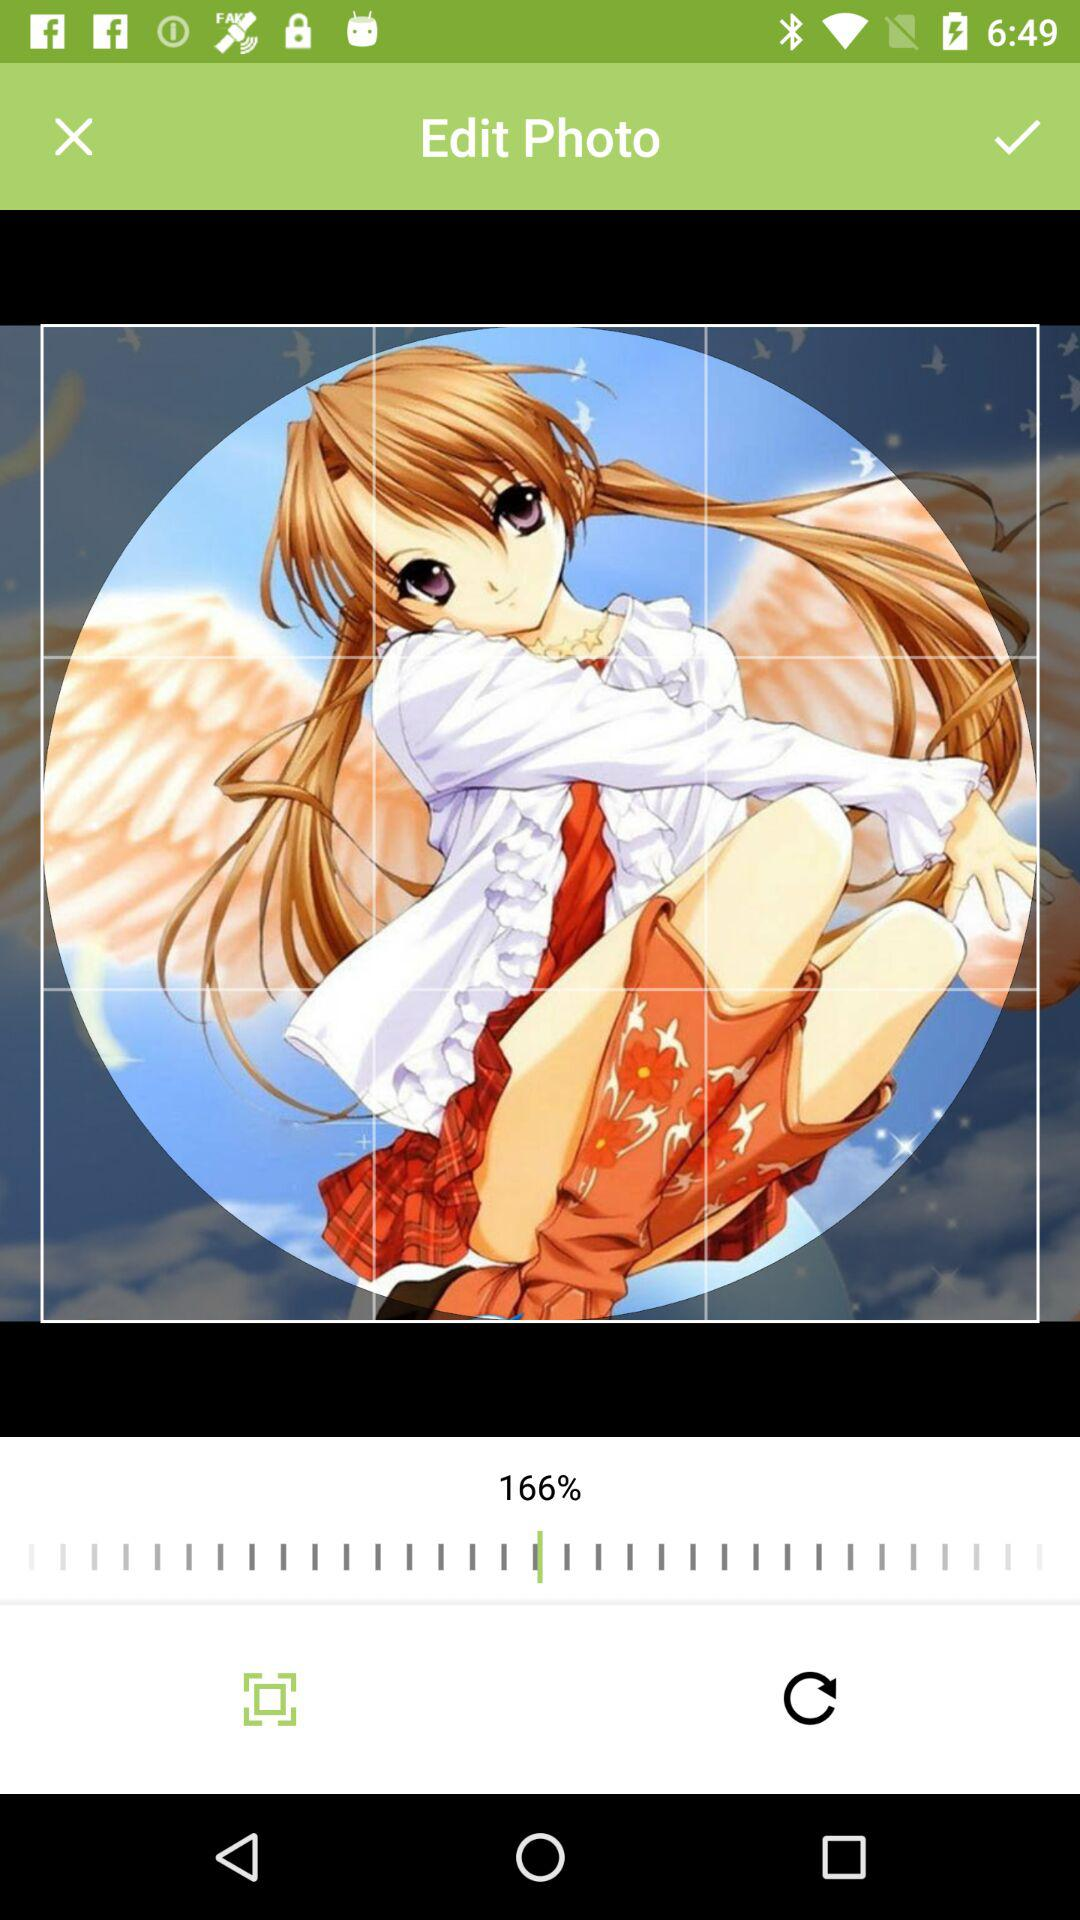What is the zoom percentage of the image? The zoom percentage of the image is 166. 